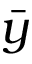Convert formula to latex. <formula><loc_0><loc_0><loc_500><loc_500>\bar { y }</formula> 